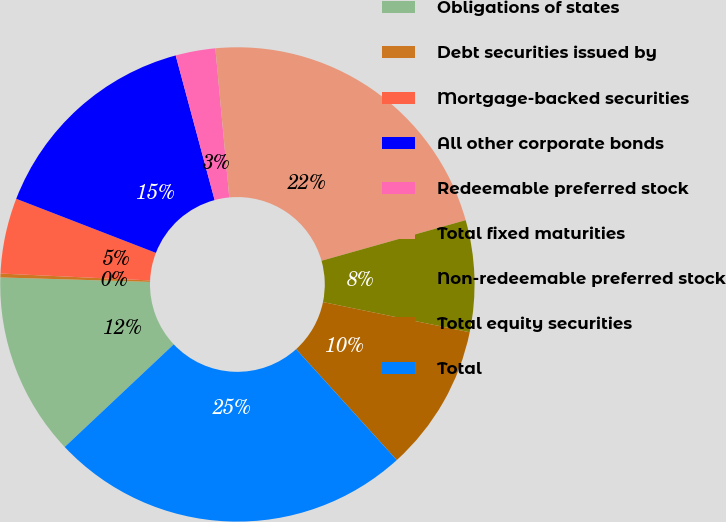Convert chart. <chart><loc_0><loc_0><loc_500><loc_500><pie_chart><fcel>Obligations of states<fcel>Debt securities issued by<fcel>Mortgage-backed securities<fcel>All other corporate bonds<fcel>Redeemable preferred stock<fcel>Total fixed maturities<fcel>Non-redeemable preferred stock<fcel>Total equity securities<fcel>Total<nl><fcel>12.49%<fcel>0.26%<fcel>5.15%<fcel>14.93%<fcel>2.71%<fcel>22.11%<fcel>7.6%<fcel>10.04%<fcel>24.71%<nl></chart> 